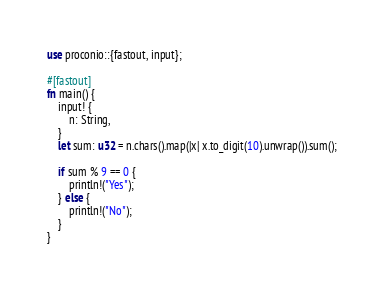Convert code to text. <code><loc_0><loc_0><loc_500><loc_500><_Rust_>use proconio::{fastout, input};

#[fastout]
fn main() {
    input! {
        n: String,
    }
    let sum: u32 = n.chars().map(|x| x.to_digit(10).unwrap()).sum();

    if sum % 9 == 0 {
        println!("Yes");
    } else {
        println!("No");
    }
}
</code> 